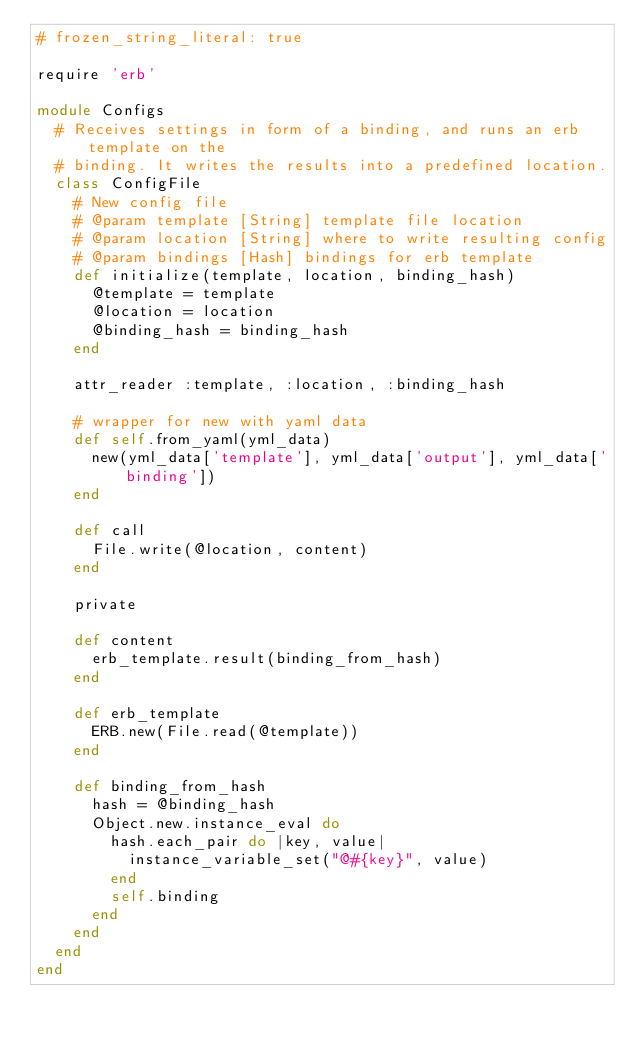Convert code to text. <code><loc_0><loc_0><loc_500><loc_500><_Ruby_># frozen_string_literal: true

require 'erb'

module Configs
  # Receives settings in form of a binding, and runs an erb template on the
  # binding. It writes the results into a predefined location.
  class ConfigFile
    # New config file
    # @param template [String] template file location
    # @param location [String] where to write resulting config
    # @param bindings [Hash] bindings for erb template
    def initialize(template, location, binding_hash)
      @template = template
      @location = location
      @binding_hash = binding_hash
    end

    attr_reader :template, :location, :binding_hash

    # wrapper for new with yaml data
    def self.from_yaml(yml_data)
      new(yml_data['template'], yml_data['output'], yml_data['binding'])
    end

    def call
      File.write(@location, content)
    end

    private

    def content
      erb_template.result(binding_from_hash)
    end

    def erb_template
      ERB.new(File.read(@template))
    end

    def binding_from_hash
      hash = @binding_hash
      Object.new.instance_eval do
        hash.each_pair do |key, value|
          instance_variable_set("@#{key}", value)
        end
        self.binding
      end
    end
  end
end
</code> 